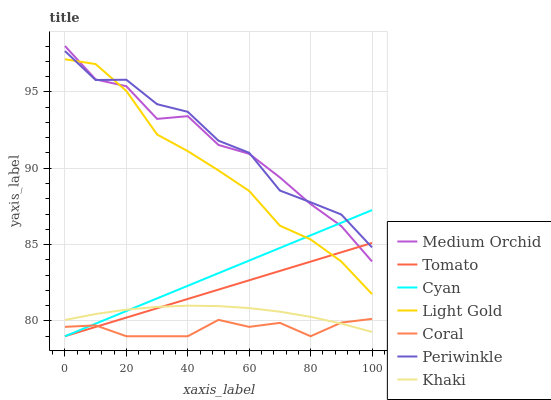Does Coral have the minimum area under the curve?
Answer yes or no. Yes. Does Periwinkle have the maximum area under the curve?
Answer yes or no. Yes. Does Khaki have the minimum area under the curve?
Answer yes or no. No. Does Khaki have the maximum area under the curve?
Answer yes or no. No. Is Cyan the smoothest?
Answer yes or no. Yes. Is Periwinkle the roughest?
Answer yes or no. Yes. Is Khaki the smoothest?
Answer yes or no. No. Is Khaki the roughest?
Answer yes or no. No. Does Tomato have the lowest value?
Answer yes or no. Yes. Does Khaki have the lowest value?
Answer yes or no. No. Does Medium Orchid have the highest value?
Answer yes or no. Yes. Does Khaki have the highest value?
Answer yes or no. No. Is Coral less than Light Gold?
Answer yes or no. Yes. Is Periwinkle greater than Khaki?
Answer yes or no. Yes. Does Tomato intersect Light Gold?
Answer yes or no. Yes. Is Tomato less than Light Gold?
Answer yes or no. No. Is Tomato greater than Light Gold?
Answer yes or no. No. Does Coral intersect Light Gold?
Answer yes or no. No. 